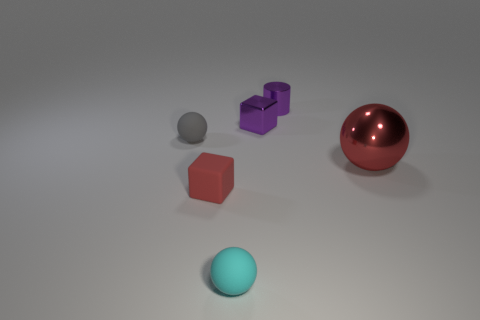Subtract all tiny cyan balls. How many balls are left? 2 Subtract all cyan balls. How many balls are left? 2 Add 3 tiny matte blocks. How many objects exist? 9 Subtract 3 balls. How many balls are left? 0 Subtract all cylinders. How many objects are left? 5 Subtract 0 blue balls. How many objects are left? 6 Subtract all red cylinders. Subtract all blue balls. How many cylinders are left? 1 Subtract all big metallic spheres. Subtract all purple metal cylinders. How many objects are left? 4 Add 5 small gray rubber spheres. How many small gray rubber spheres are left? 6 Add 1 red shiny balls. How many red shiny balls exist? 2 